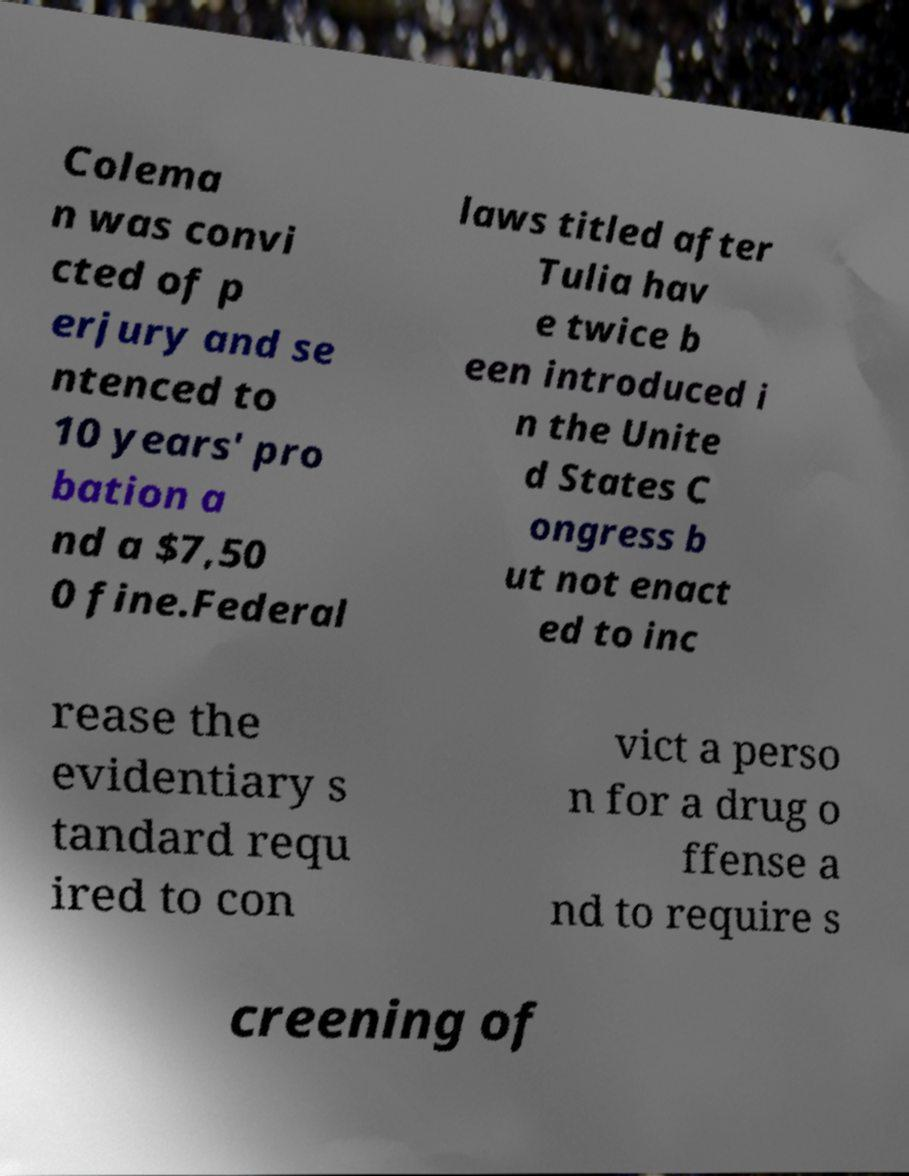Can you read and provide the text displayed in the image?This photo seems to have some interesting text. Can you extract and type it out for me? Colema n was convi cted of p erjury and se ntenced to 10 years' pro bation a nd a $7,50 0 fine.Federal laws titled after Tulia hav e twice b een introduced i n the Unite d States C ongress b ut not enact ed to inc rease the evidentiary s tandard requ ired to con vict a perso n for a drug o ffense a nd to require s creening of 